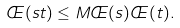<formula> <loc_0><loc_0><loc_500><loc_500>\phi ( s t ) \leq M \phi ( s ) \phi ( t ) .</formula> 